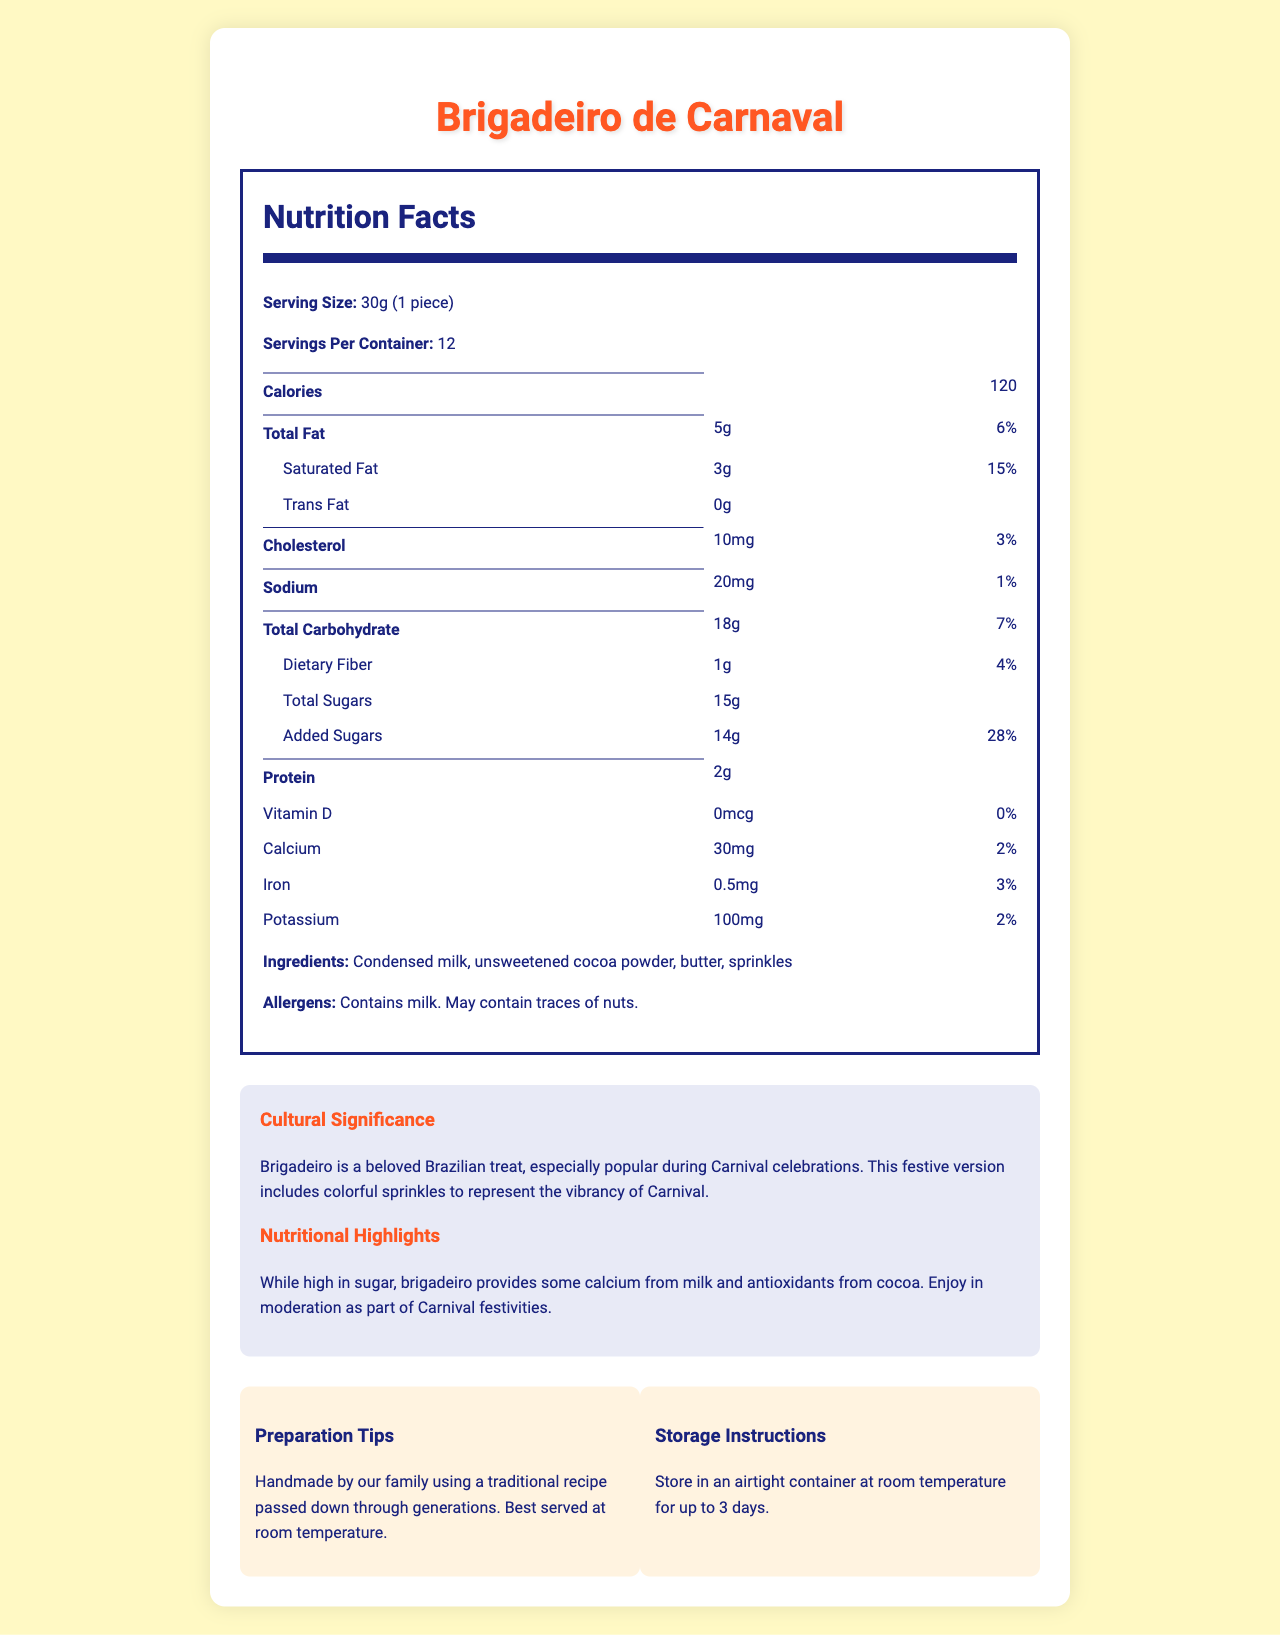what is the serving size? The serving size is mentioned at the top of the Nutrition Facts section, where it states "Serving Size: 30g (1 piece)".
Answer: 30g (1 piece) how many servings are in the container? The number of servings per container is specified right below the serving size as "Servings Per Container: 12".
Answer: 12 how many calories are in one piece of Brigadeiro de Carnaval? The calorie content is listed immediately under the servings per container, where it states "Calories: 120".
Answer: 120 what is the total fat content per serving? The total fat content per serving is listed under the Total Fat section as "Total Fat: 5g".
Answer: 5g how much added sugar does one piece contain? The amount of added sugars per serving is listed under the Total Carbohydrate section as "Added Sugars: 14g".
Answer: 14g what percentage of the daily value of saturated fat is in one serving? This can be found in the Saturated Fat section as "Saturated Fat: 3g, Daily Value: 15%".
Answer: 15% which of the following is part of the ingredients in Brigadeiro de Carnaval? A. Almonds B. Honey C. Condensed milk D. Peanuts The ingredients are listed as "Condensed milk, unsweetened cocoa powder, butter, sprinkles".
Answer: C what is the daily value percentage of calcium per serving? A. 1% B. 2% C. 3% D. 4% The daily value percentage for calcium per serving is listed as "Calcium: 30mg, Daily Value: 2%".
Answer: B does the product contain any allergens? The allergens information states "Contains milk. May contain traces of nuts."
Answer: Yes is this product suitable for a dairy-free diet? The product contains milk, which makes it unsuitable for a dairy-free diet.
Answer: No summarize the main idea of the document The document is a comprehensive Nutrition Facts Label for Brigadeiro de Carnaval, detailing its nutritional contents, highlighting its cultural ties to Brazilian Carnival, and offering preparation and storage methods.
Answer: The document provides detailed nutritional information about the "Brigadeiro de Carnaval", a traditional Brazilian dessert popular during Carnival. It includes serving size, calorie count, macronutrient breakdown, vitamins and minerals, ingredients, allergen information, cultural significance, nutritional highlights, preparation tips, and storage instructions. what is the cultural significance of Brigadeiro de Carnaval according to the document? The cultural significance section explains that Brigadeiro is a beloved Brazilian treat, particularly during Carnival, and that the colorful sprinkles are meant to reflect the vibrancy of the celebration.
Answer: Brigadeiro is a beloved Brazilian treat, especially popular during Carnival celebrations. This festive version includes colorful sprinkles to represent the vibrancy of Carnival. what percentage of the daily value of dietary fiber is in one piece? The dietary fiber content per serving is listed as "Dietary Fiber: 1g, Daily Value: 4%".
Answer: 4% what company manufactures Brigadeiro de Carnaval? The document does not provide any information about the company that manufactures Brigadeiro de Carnaval.
Answer: Not enough information 